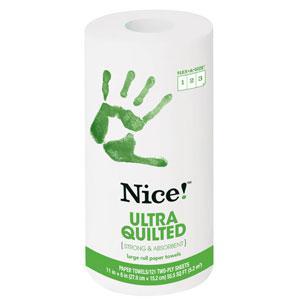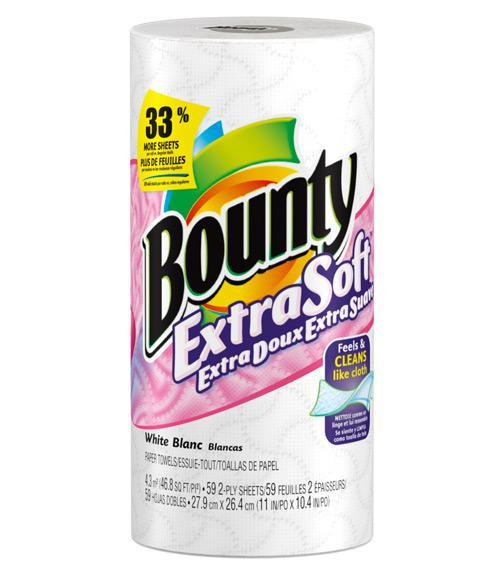The first image is the image on the left, the second image is the image on the right. Considering the images on both sides, is "The left image shows one multi-roll package of towels with a starburst shape on the front of the pack, and the package on the right features a blue curving line." valid? Answer yes or no. No. The first image is the image on the left, the second image is the image on the right. Given the left and right images, does the statement "There are two multi-packs of paper towels." hold true? Answer yes or no. No. 